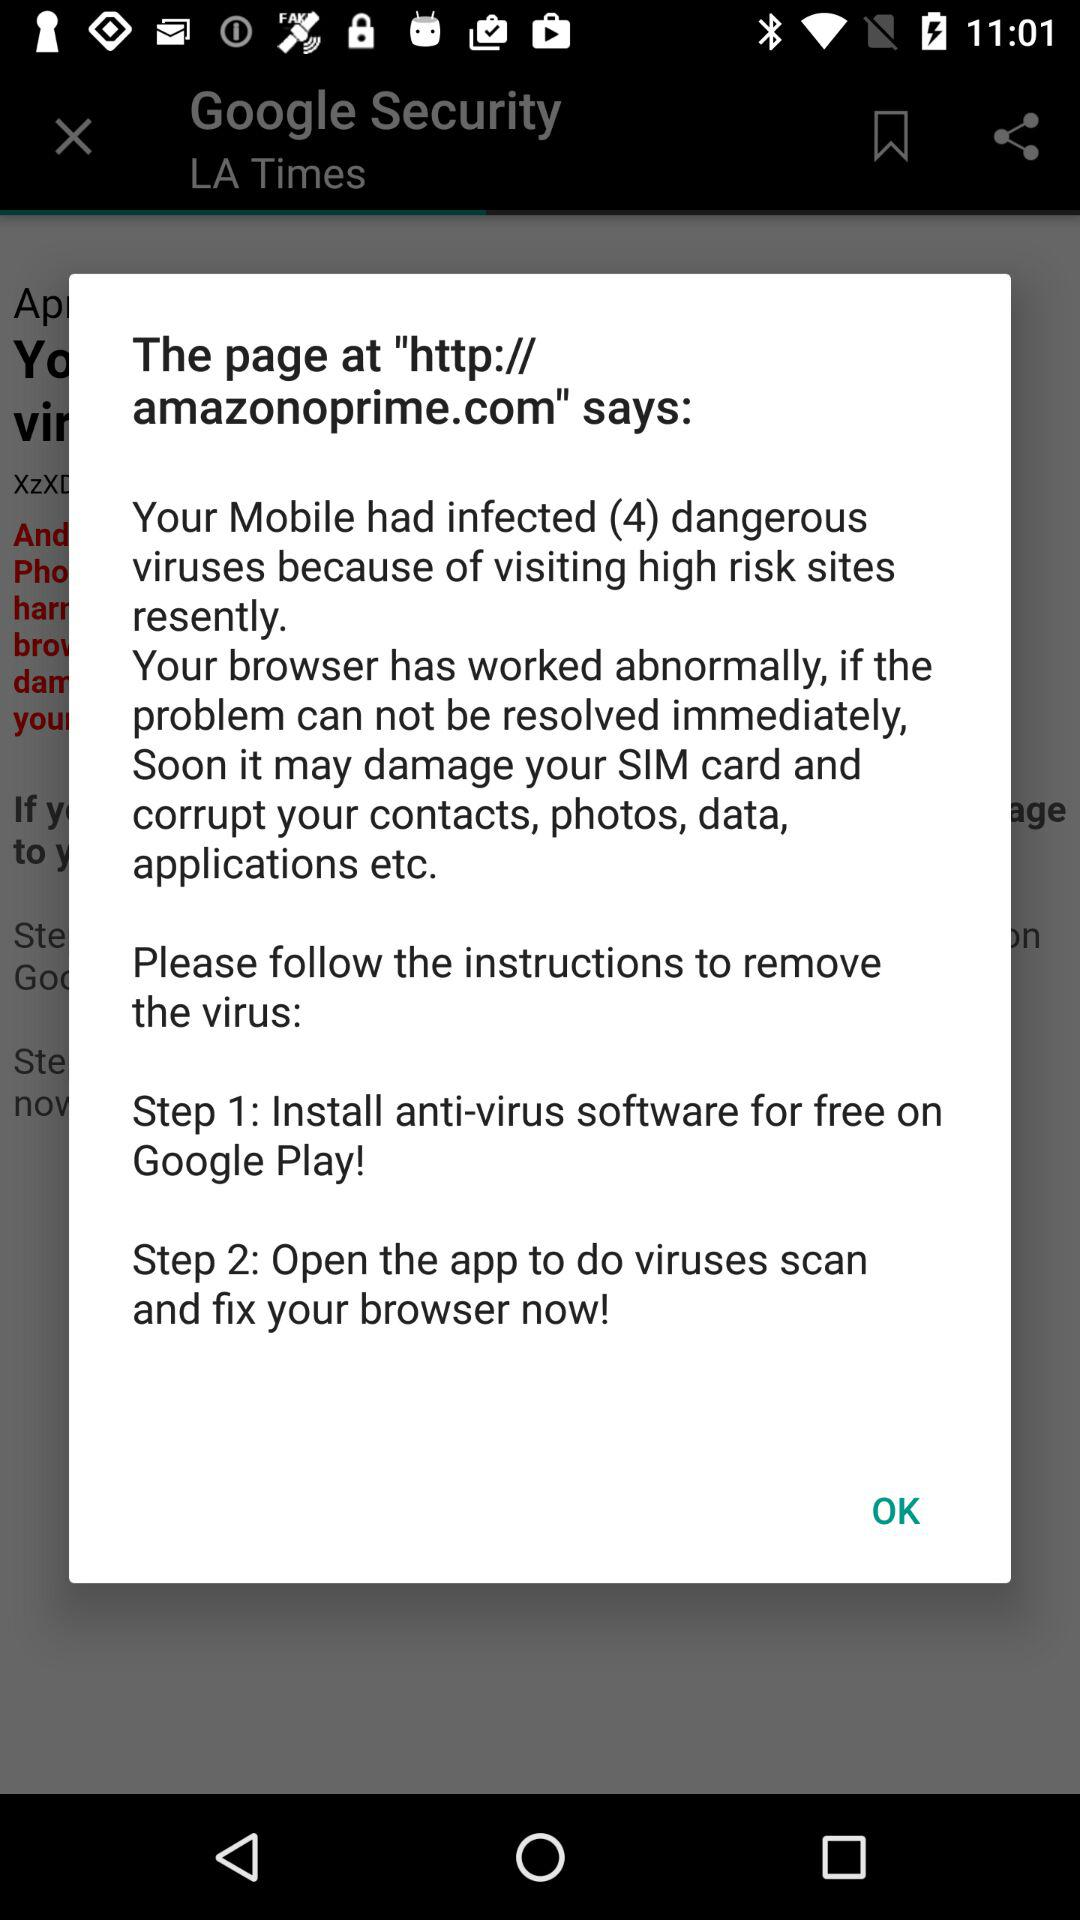How many dangerous viruses have infected the mobile?
Answer the question using a single word or phrase. 4 